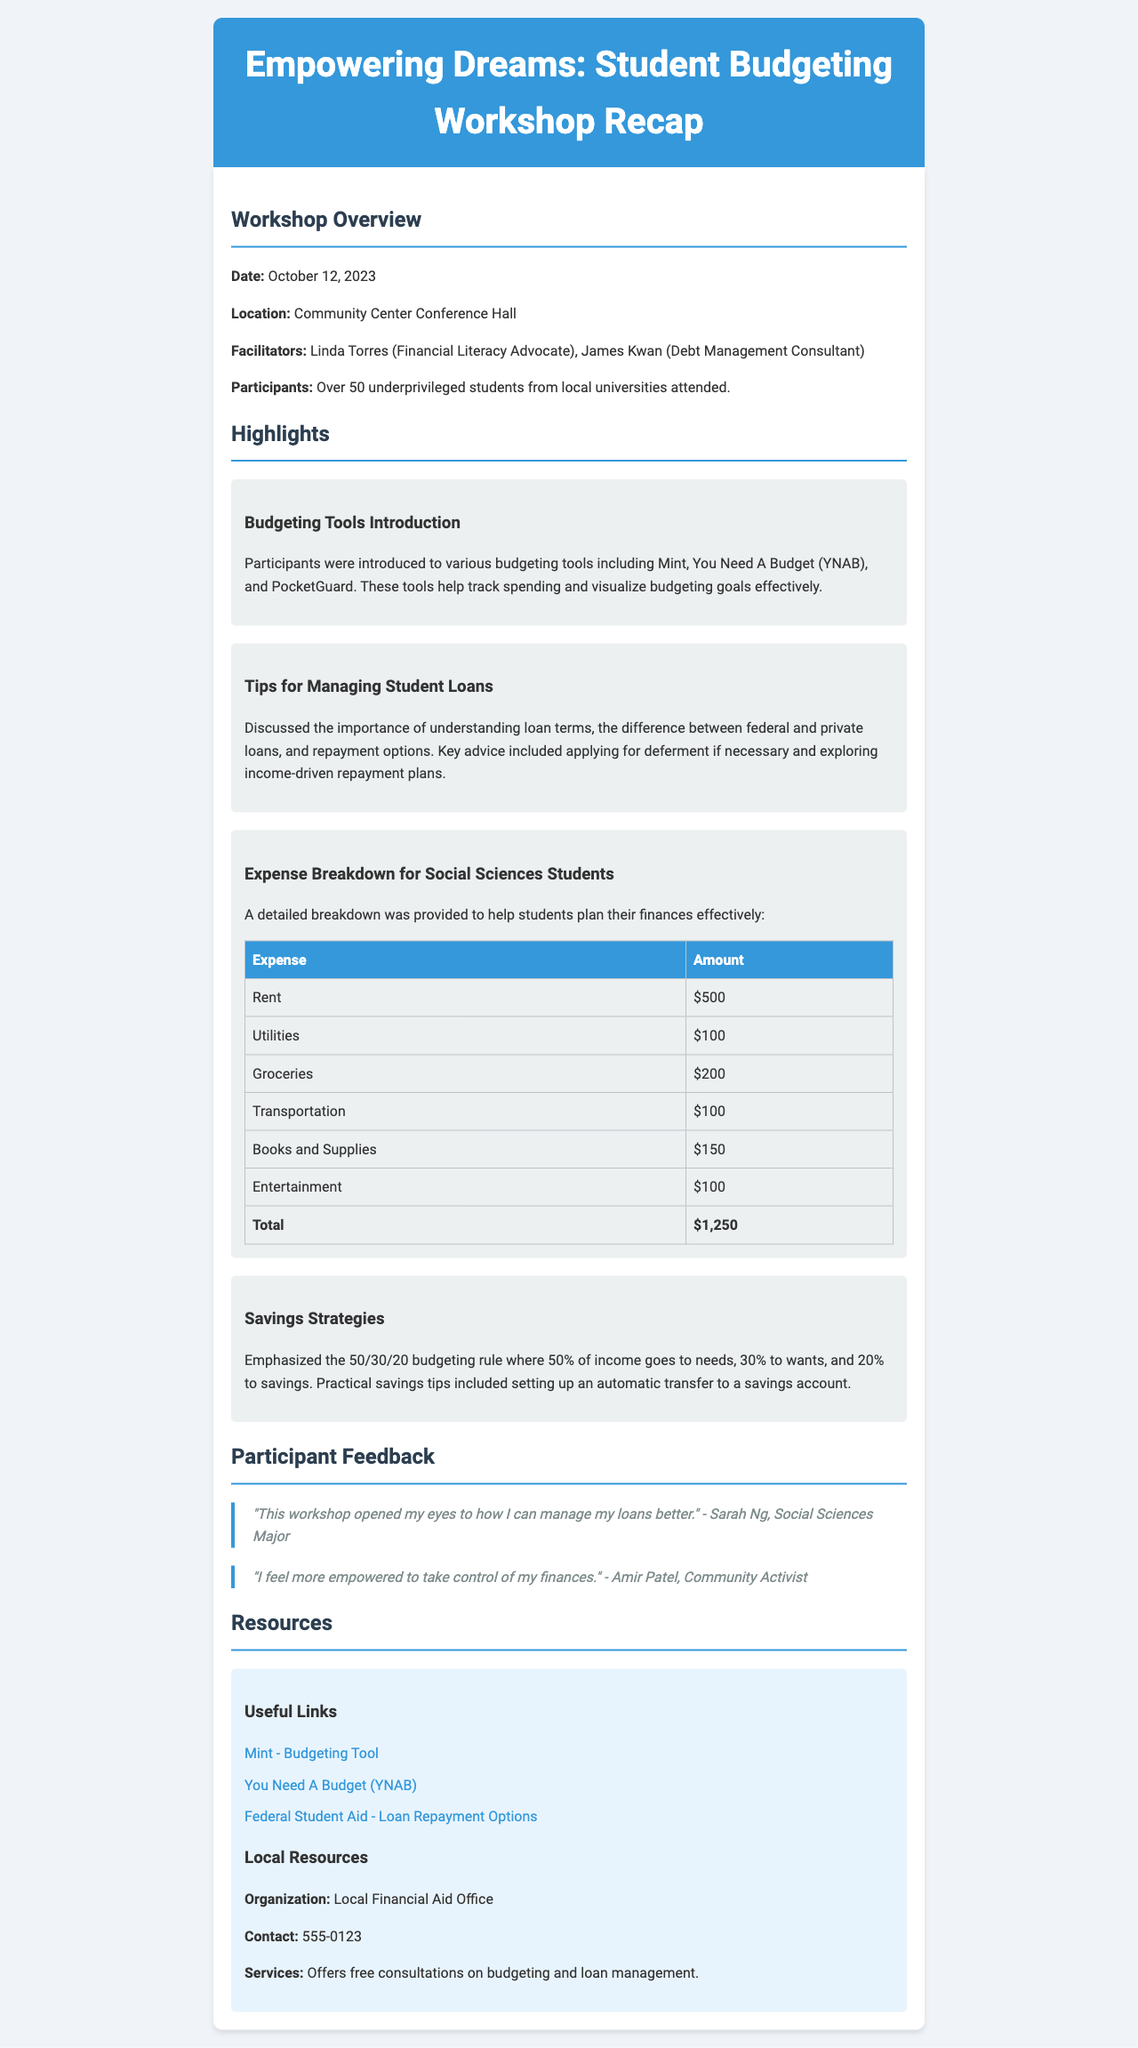What was the date of the workshop? The document specifies that the workshop was held on October 12, 2023.
Answer: October 12, 2023 Who facilitated the workshop? The facilitators listed in the document are Linda Torres and James Kwan.
Answer: Linda Torres and James Kwan How many students attended the workshop? The document states that over 50 students participated in the workshop.
Answer: Over 50 What is the total estimated monthly expense for a social sciences student? The total of listed expenses amounts to $1,250 according to the expense breakdown in the document.
Answer: $1,250 What budgeting tools were introduced during the workshop? The document mentions Mint, You Need A Budget (YNAB), and PocketGuard as budgeting tools discussed in the workshop.
Answer: Mint, You Need A Budget (YNAB), PocketGuard What is the 50/30/20 budgeting rule? This rule is summarized in the document as allocating 50% for needs, 30% for wants, and 20% for savings.
Answer: 50% needs, 30% wants, 20% savings What services does the Local Financial Aid Office offer? The document indicates that the Local Financial Aid Office offers free consultations on budgeting and loan management.
Answer: Free consultations on budgeting and loan management What was a key piece of advice regarding student loans? The document highlights the importance of applying for deferment if necessary as key advice for managing loans.
Answer: Applying for deferment if necessary 